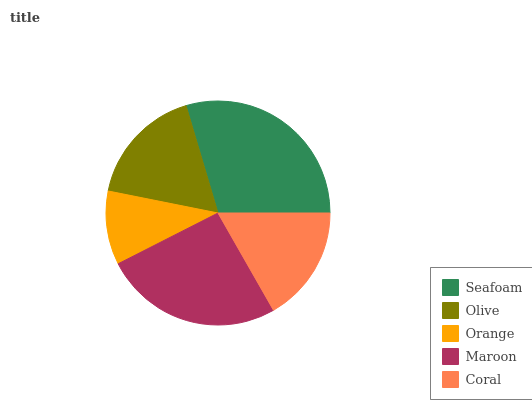Is Orange the minimum?
Answer yes or no. Yes. Is Seafoam the maximum?
Answer yes or no. Yes. Is Olive the minimum?
Answer yes or no. No. Is Olive the maximum?
Answer yes or no. No. Is Seafoam greater than Olive?
Answer yes or no. Yes. Is Olive less than Seafoam?
Answer yes or no. Yes. Is Olive greater than Seafoam?
Answer yes or no. No. Is Seafoam less than Olive?
Answer yes or no. No. Is Olive the high median?
Answer yes or no. Yes. Is Olive the low median?
Answer yes or no. Yes. Is Coral the high median?
Answer yes or no. No. Is Coral the low median?
Answer yes or no. No. 